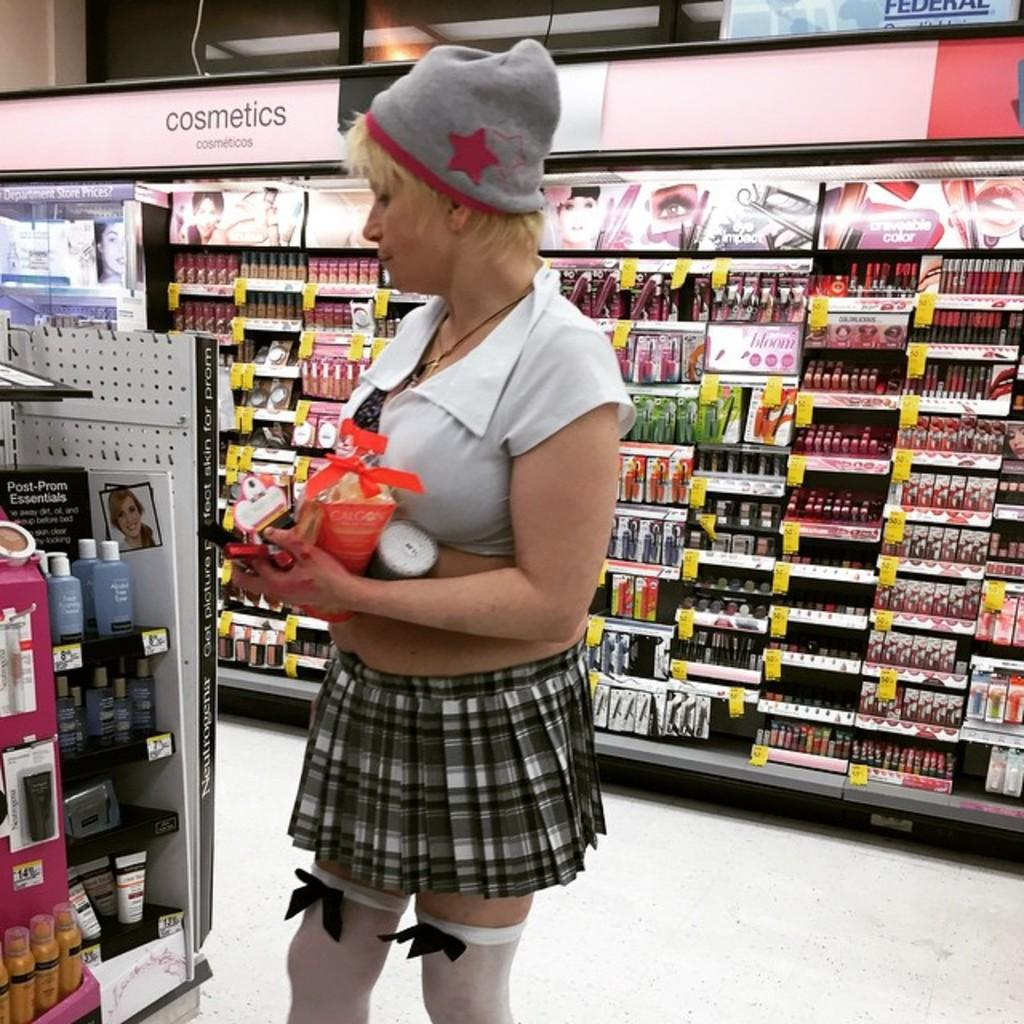<image>
Offer a succinct explanation of the picture presented. A blonde woman wearing a school girl costume by the cosmetics section of a store. 